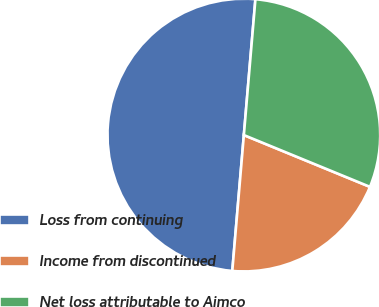<chart> <loc_0><loc_0><loc_500><loc_500><pie_chart><fcel>Loss from continuing<fcel>Income from discontinued<fcel>Net loss attributable to Aimco<nl><fcel>50.0%<fcel>20.15%<fcel>29.85%<nl></chart> 